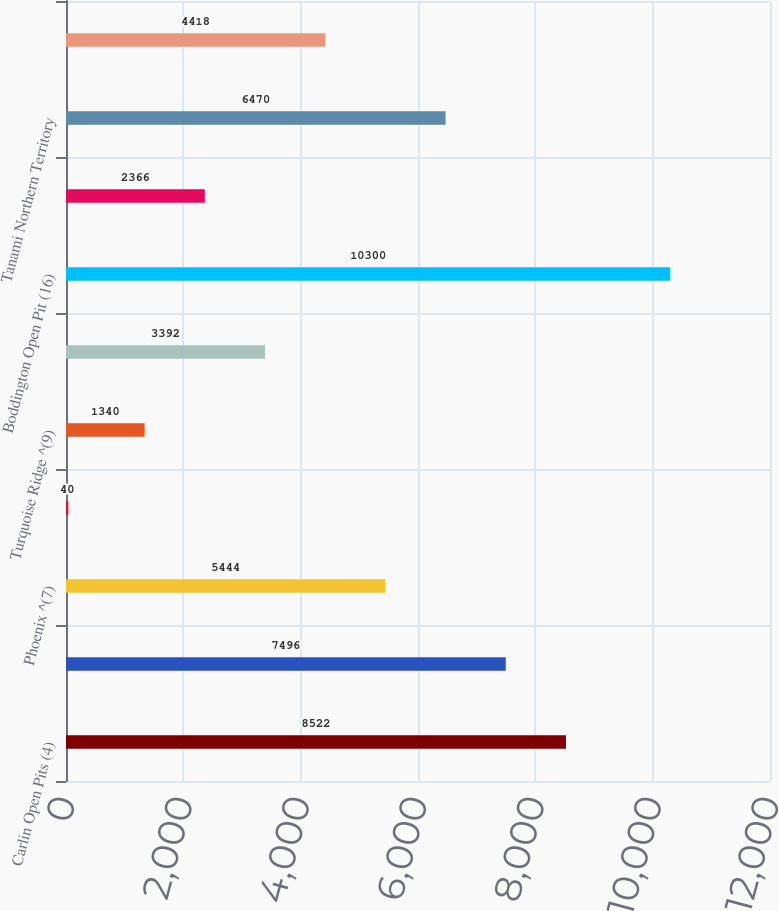Convert chart. <chart><loc_0><loc_0><loc_500><loc_500><bar_chart><fcel>Carlin Open Pits (4)<fcel>Carlin Underground ^(6)<fcel>Phoenix ^(7)<fcel>Lone Tree ^(8)<fcel>Turquoise Ridge ^(9)<fcel>Yanacocha Open Pits ^(14)<fcel>Boddington Open Pit (16)<fcel>Boddington Stockpiles ^(5)<fcel>Tanami Northern Territory<fcel>Ahafo South Open Pits ^(19)<nl><fcel>8522<fcel>7496<fcel>5444<fcel>40<fcel>1340<fcel>3392<fcel>10300<fcel>2366<fcel>6470<fcel>4418<nl></chart> 